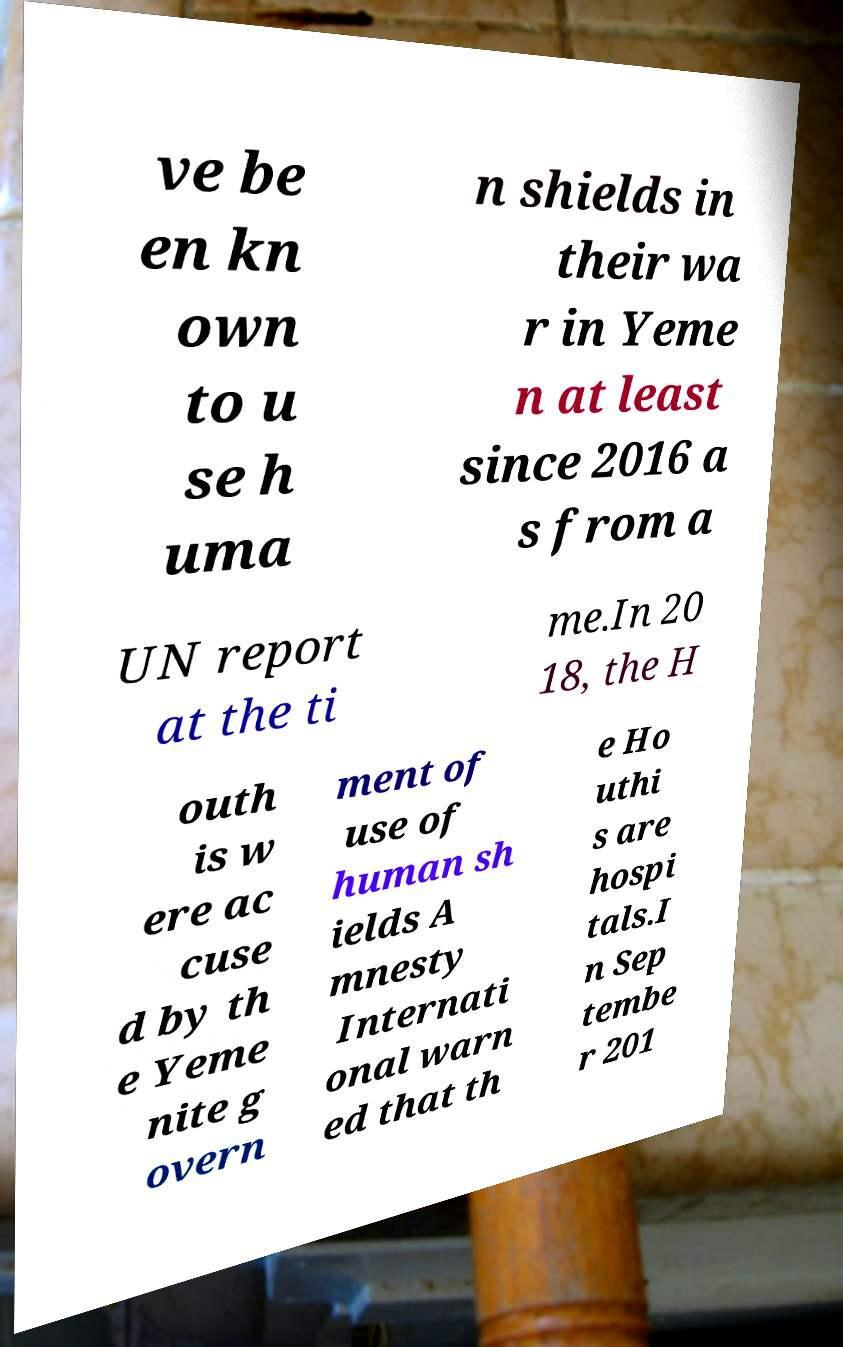There's text embedded in this image that I need extracted. Can you transcribe it verbatim? ve be en kn own to u se h uma n shields in their wa r in Yeme n at least since 2016 a s from a UN report at the ti me.In 20 18, the H outh is w ere ac cuse d by th e Yeme nite g overn ment of use of human sh ields A mnesty Internati onal warn ed that th e Ho uthi s are hospi tals.I n Sep tembe r 201 